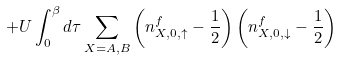<formula> <loc_0><loc_0><loc_500><loc_500>+ U \int _ { 0 } ^ { \beta } d \tau \sum _ { X = A , B } \left ( n ^ { f } _ { X , 0 , \uparrow } - \frac { 1 } { 2 } \right ) \left ( n ^ { f } _ { X , 0 , \downarrow } - \frac { 1 } { 2 } \right )</formula> 